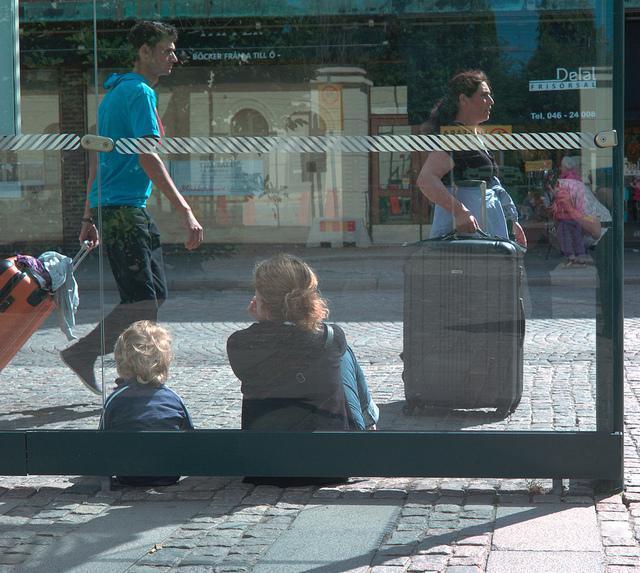How many children are on the sidewalk?
Give a very brief answer. 2. How many suitcases are there?
Give a very brief answer. 2. How many people are there?
Give a very brief answer. 5. How many horses are there?
Give a very brief answer. 0. 